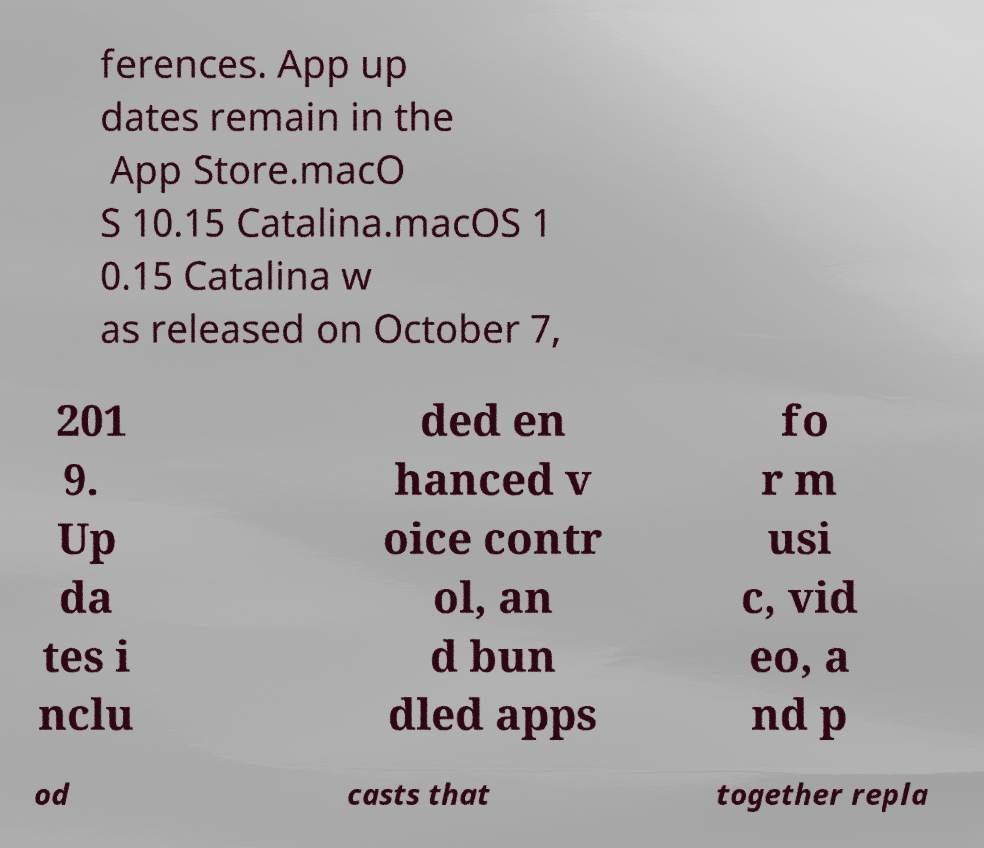Could you assist in decoding the text presented in this image and type it out clearly? ferences. App up dates remain in the App Store.macO S 10.15 Catalina.macOS 1 0.15 Catalina w as released on October 7, 201 9. Up da tes i nclu ded en hanced v oice contr ol, an d bun dled apps fo r m usi c, vid eo, a nd p od casts that together repla 